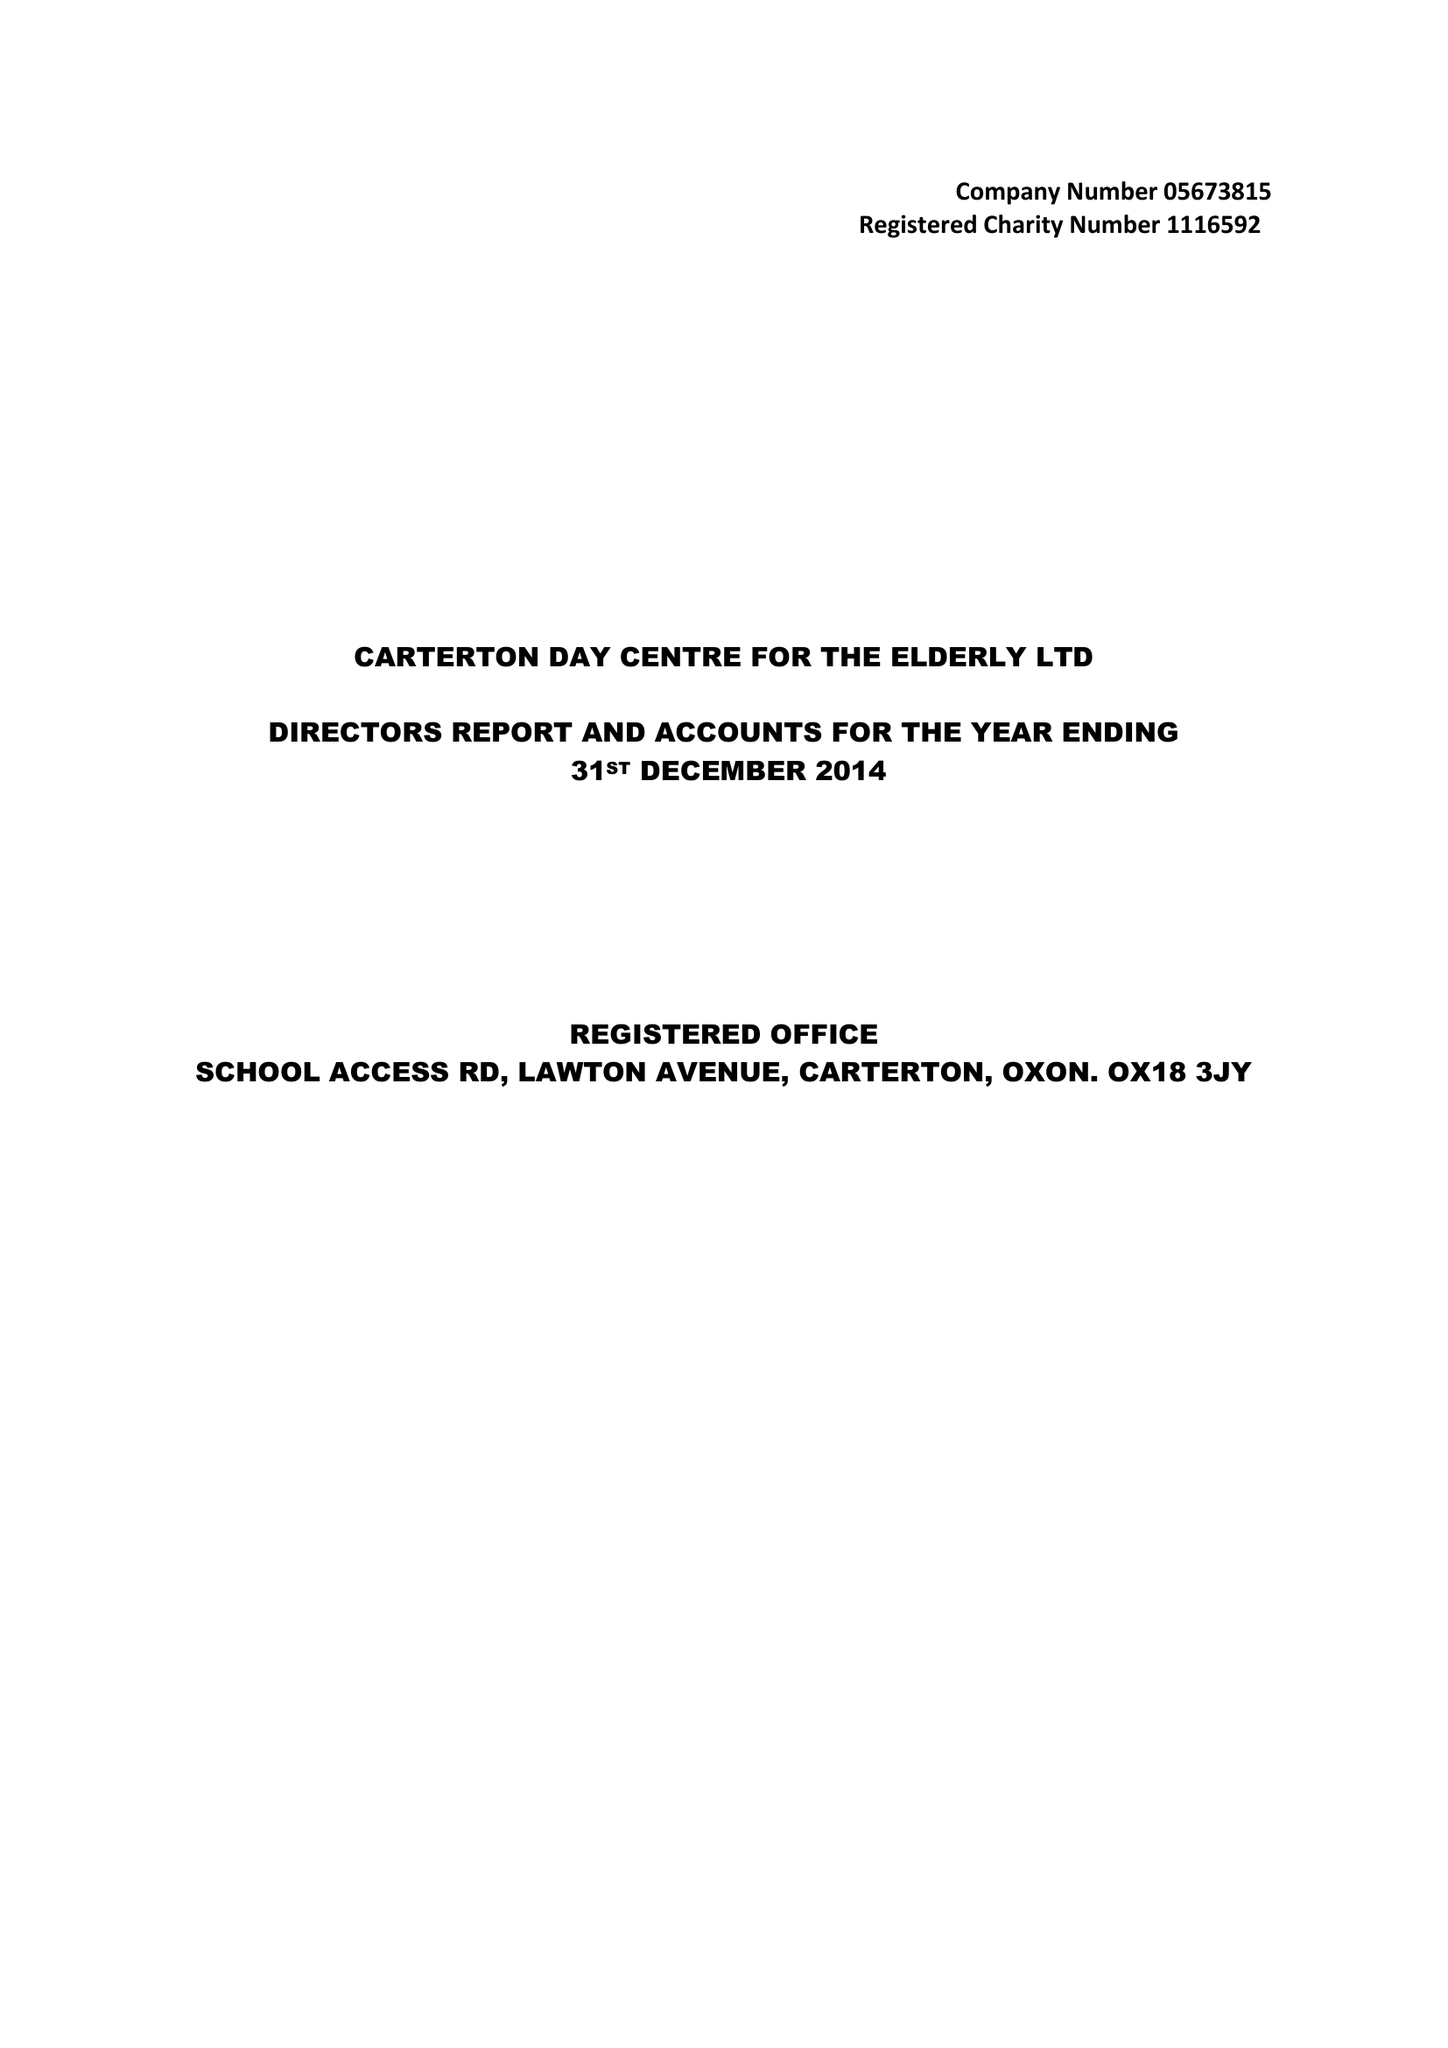What is the value for the report_date?
Answer the question using a single word or phrase. 2014-12-31 